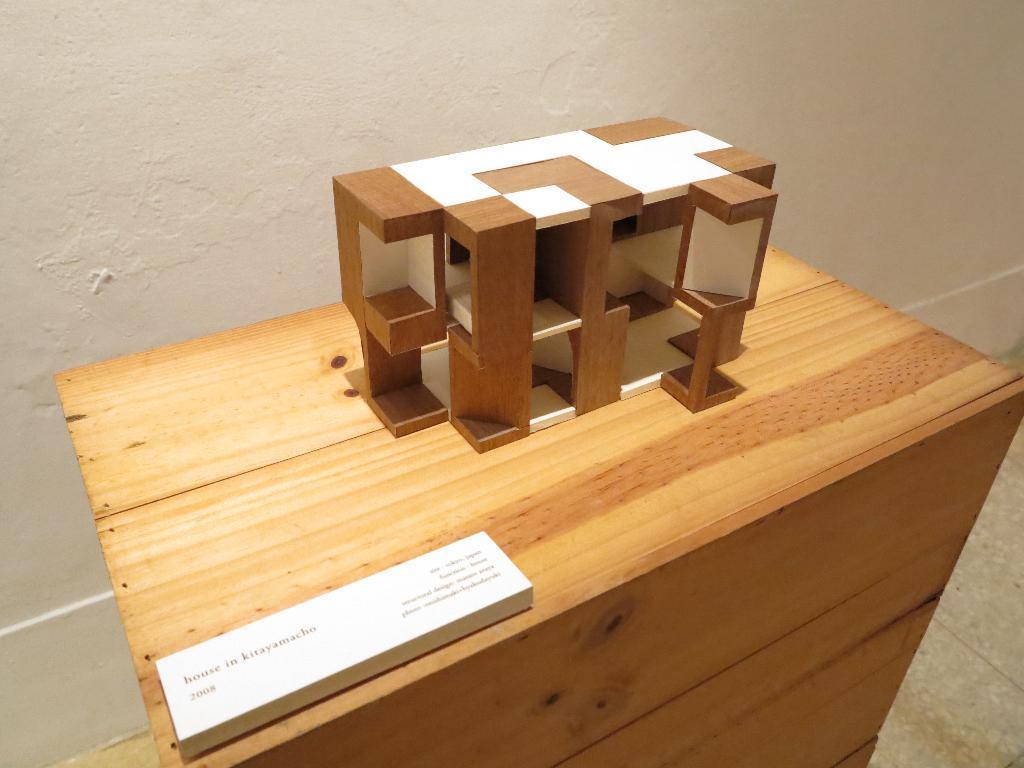Describe this image in one or two sentences. In the center of the image we can see a table. On the table we can see a board and architecture of a building. In the background of the image we can see the wall. At the bottom of the image we can see the floor. 